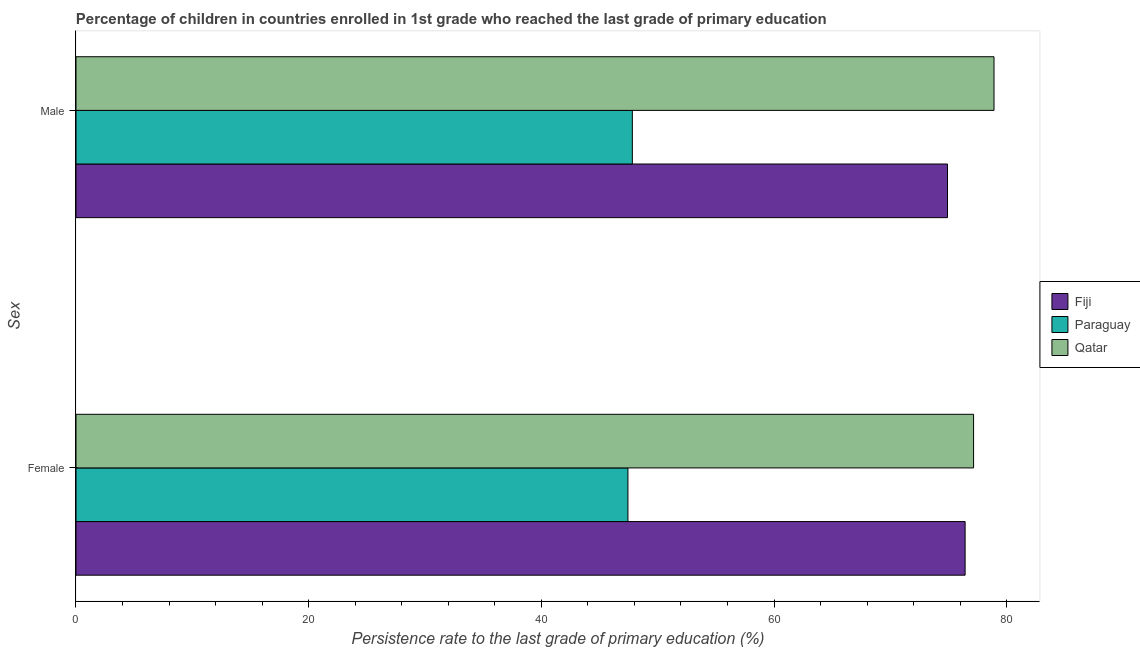Are the number of bars per tick equal to the number of legend labels?
Keep it short and to the point. Yes. What is the persistence rate of female students in Fiji?
Provide a short and direct response. 76.43. Across all countries, what is the maximum persistence rate of male students?
Keep it short and to the point. 78.91. Across all countries, what is the minimum persistence rate of male students?
Provide a succinct answer. 47.82. In which country was the persistence rate of male students maximum?
Offer a very short reply. Qatar. In which country was the persistence rate of female students minimum?
Your response must be concise. Paraguay. What is the total persistence rate of male students in the graph?
Keep it short and to the point. 201.65. What is the difference between the persistence rate of female students in Paraguay and that in Qatar?
Ensure brevity in your answer.  -29.71. What is the difference between the persistence rate of male students in Fiji and the persistence rate of female students in Paraguay?
Your response must be concise. 27.47. What is the average persistence rate of male students per country?
Keep it short and to the point. 67.22. What is the difference between the persistence rate of female students and persistence rate of male students in Paraguay?
Keep it short and to the point. -0.38. In how many countries, is the persistence rate of female students greater than 76 %?
Offer a very short reply. 2. What is the ratio of the persistence rate of male students in Qatar to that in Paraguay?
Offer a very short reply. 1.65. In how many countries, is the persistence rate of male students greater than the average persistence rate of male students taken over all countries?
Give a very brief answer. 2. What does the 1st bar from the top in Female represents?
Give a very brief answer. Qatar. What does the 2nd bar from the bottom in Female represents?
Your answer should be compact. Paraguay. How many bars are there?
Give a very brief answer. 6. How many countries are there in the graph?
Give a very brief answer. 3. What is the difference between two consecutive major ticks on the X-axis?
Your answer should be compact. 20. Are the values on the major ticks of X-axis written in scientific E-notation?
Your response must be concise. No. Does the graph contain any zero values?
Give a very brief answer. No. How are the legend labels stacked?
Your response must be concise. Vertical. What is the title of the graph?
Offer a terse response. Percentage of children in countries enrolled in 1st grade who reached the last grade of primary education. Does "Vietnam" appear as one of the legend labels in the graph?
Keep it short and to the point. No. What is the label or title of the X-axis?
Offer a terse response. Persistence rate to the last grade of primary education (%). What is the label or title of the Y-axis?
Provide a succinct answer. Sex. What is the Persistence rate to the last grade of primary education (%) in Fiji in Female?
Keep it short and to the point. 76.43. What is the Persistence rate to the last grade of primary education (%) of Paraguay in Female?
Your response must be concise. 47.44. What is the Persistence rate to the last grade of primary education (%) of Qatar in Female?
Make the answer very short. 77.15. What is the Persistence rate to the last grade of primary education (%) in Fiji in Male?
Provide a succinct answer. 74.91. What is the Persistence rate to the last grade of primary education (%) of Paraguay in Male?
Your answer should be compact. 47.82. What is the Persistence rate to the last grade of primary education (%) in Qatar in Male?
Your answer should be very brief. 78.91. Across all Sex, what is the maximum Persistence rate to the last grade of primary education (%) of Fiji?
Your response must be concise. 76.43. Across all Sex, what is the maximum Persistence rate to the last grade of primary education (%) in Paraguay?
Provide a short and direct response. 47.82. Across all Sex, what is the maximum Persistence rate to the last grade of primary education (%) of Qatar?
Keep it short and to the point. 78.91. Across all Sex, what is the minimum Persistence rate to the last grade of primary education (%) in Fiji?
Give a very brief answer. 74.91. Across all Sex, what is the minimum Persistence rate to the last grade of primary education (%) of Paraguay?
Offer a very short reply. 47.44. Across all Sex, what is the minimum Persistence rate to the last grade of primary education (%) in Qatar?
Provide a short and direct response. 77.15. What is the total Persistence rate to the last grade of primary education (%) of Fiji in the graph?
Make the answer very short. 151.34. What is the total Persistence rate to the last grade of primary education (%) in Paraguay in the graph?
Make the answer very short. 95.27. What is the total Persistence rate to the last grade of primary education (%) in Qatar in the graph?
Ensure brevity in your answer.  156.07. What is the difference between the Persistence rate to the last grade of primary education (%) of Fiji in Female and that in Male?
Your response must be concise. 1.51. What is the difference between the Persistence rate to the last grade of primary education (%) in Paraguay in Female and that in Male?
Your answer should be compact. -0.38. What is the difference between the Persistence rate to the last grade of primary education (%) in Qatar in Female and that in Male?
Ensure brevity in your answer.  -1.76. What is the difference between the Persistence rate to the last grade of primary education (%) in Fiji in Female and the Persistence rate to the last grade of primary education (%) in Paraguay in Male?
Provide a short and direct response. 28.6. What is the difference between the Persistence rate to the last grade of primary education (%) in Fiji in Female and the Persistence rate to the last grade of primary education (%) in Qatar in Male?
Keep it short and to the point. -2.48. What is the difference between the Persistence rate to the last grade of primary education (%) in Paraguay in Female and the Persistence rate to the last grade of primary education (%) in Qatar in Male?
Your answer should be compact. -31.47. What is the average Persistence rate to the last grade of primary education (%) of Fiji per Sex?
Provide a short and direct response. 75.67. What is the average Persistence rate to the last grade of primary education (%) in Paraguay per Sex?
Provide a succinct answer. 47.63. What is the average Persistence rate to the last grade of primary education (%) in Qatar per Sex?
Offer a terse response. 78.03. What is the difference between the Persistence rate to the last grade of primary education (%) in Fiji and Persistence rate to the last grade of primary education (%) in Paraguay in Female?
Make the answer very short. 28.98. What is the difference between the Persistence rate to the last grade of primary education (%) of Fiji and Persistence rate to the last grade of primary education (%) of Qatar in Female?
Make the answer very short. -0.73. What is the difference between the Persistence rate to the last grade of primary education (%) in Paraguay and Persistence rate to the last grade of primary education (%) in Qatar in Female?
Offer a terse response. -29.71. What is the difference between the Persistence rate to the last grade of primary education (%) in Fiji and Persistence rate to the last grade of primary education (%) in Paraguay in Male?
Provide a short and direct response. 27.09. What is the difference between the Persistence rate to the last grade of primary education (%) in Fiji and Persistence rate to the last grade of primary education (%) in Qatar in Male?
Provide a succinct answer. -4. What is the difference between the Persistence rate to the last grade of primary education (%) of Paraguay and Persistence rate to the last grade of primary education (%) of Qatar in Male?
Give a very brief answer. -31.09. What is the ratio of the Persistence rate to the last grade of primary education (%) in Fiji in Female to that in Male?
Your answer should be compact. 1.02. What is the ratio of the Persistence rate to the last grade of primary education (%) in Qatar in Female to that in Male?
Provide a succinct answer. 0.98. What is the difference between the highest and the second highest Persistence rate to the last grade of primary education (%) of Fiji?
Your answer should be very brief. 1.51. What is the difference between the highest and the second highest Persistence rate to the last grade of primary education (%) of Paraguay?
Ensure brevity in your answer.  0.38. What is the difference between the highest and the second highest Persistence rate to the last grade of primary education (%) in Qatar?
Your answer should be very brief. 1.76. What is the difference between the highest and the lowest Persistence rate to the last grade of primary education (%) in Fiji?
Offer a very short reply. 1.51. What is the difference between the highest and the lowest Persistence rate to the last grade of primary education (%) of Paraguay?
Offer a very short reply. 0.38. What is the difference between the highest and the lowest Persistence rate to the last grade of primary education (%) in Qatar?
Keep it short and to the point. 1.76. 